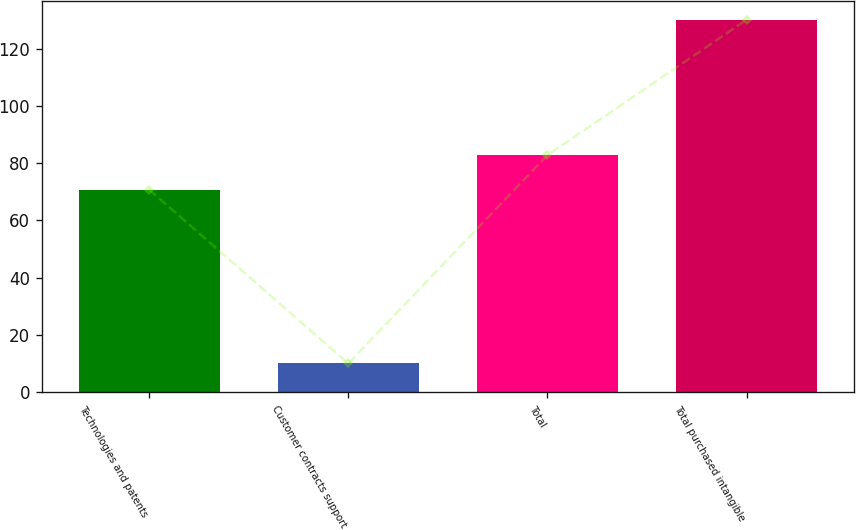<chart> <loc_0><loc_0><loc_500><loc_500><bar_chart><fcel>Technologies and patents<fcel>Customer contracts support<fcel>Total<fcel>Total purchased intangible<nl><fcel>70.8<fcel>10<fcel>82.82<fcel>130.2<nl></chart> 